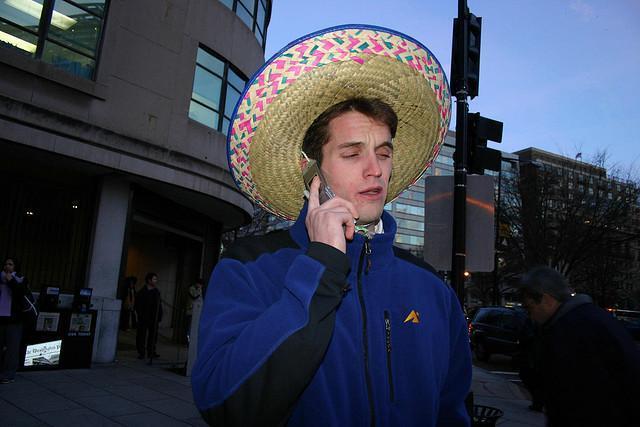How many people are in the picture?
Give a very brief answer. 3. 